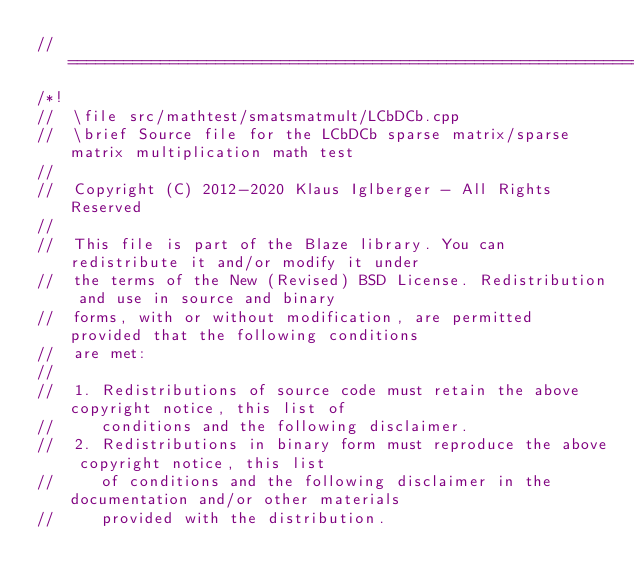<code> <loc_0><loc_0><loc_500><loc_500><_C++_>//=================================================================================================
/*!
//  \file src/mathtest/smatsmatmult/LCbDCb.cpp
//  \brief Source file for the LCbDCb sparse matrix/sparse matrix multiplication math test
//
//  Copyright (C) 2012-2020 Klaus Iglberger - All Rights Reserved
//
//  This file is part of the Blaze library. You can redistribute it and/or modify it under
//  the terms of the New (Revised) BSD License. Redistribution and use in source and binary
//  forms, with or without modification, are permitted provided that the following conditions
//  are met:
//
//  1. Redistributions of source code must retain the above copyright notice, this list of
//     conditions and the following disclaimer.
//  2. Redistributions in binary form must reproduce the above copyright notice, this list
//     of conditions and the following disclaimer in the documentation and/or other materials
//     provided with the distribution.</code> 